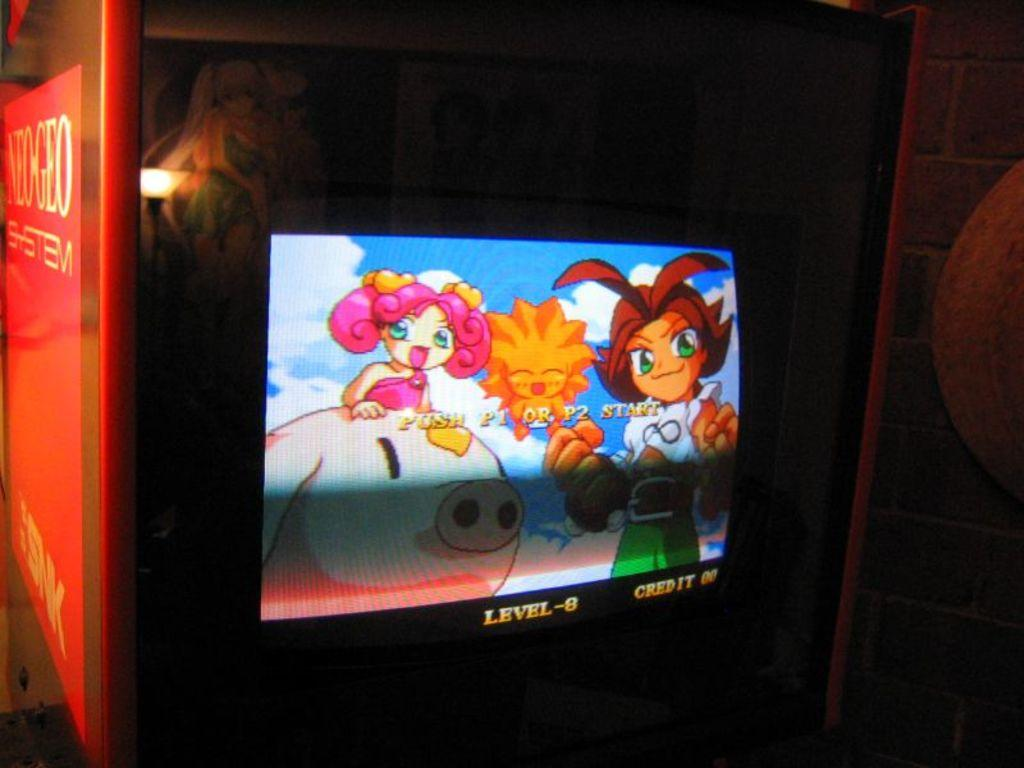<image>
Relay a brief, clear account of the picture shown. A monitor shows a game on level 8 and credit of 0. 